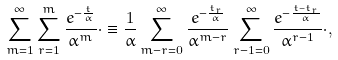Convert formula to latex. <formula><loc_0><loc_0><loc_500><loc_500>\sum _ { m = 1 } ^ { \infty } \sum _ { r = 1 } ^ { m } \frac { e ^ { - \frac { t } { \alpha } } } { \alpha ^ { m } } \cdot \equiv \frac { 1 } { \alpha } \sum _ { m - r = 0 } ^ { \infty } \frac { e ^ { - \frac { t _ { r } } { \alpha } } } { \alpha ^ { m - r } } \sum _ { r - 1 = 0 } ^ { \infty } \frac { e ^ { - \frac { t - t _ { r } } { \alpha } } } { \alpha ^ { r - 1 } } \cdot ,</formula> 